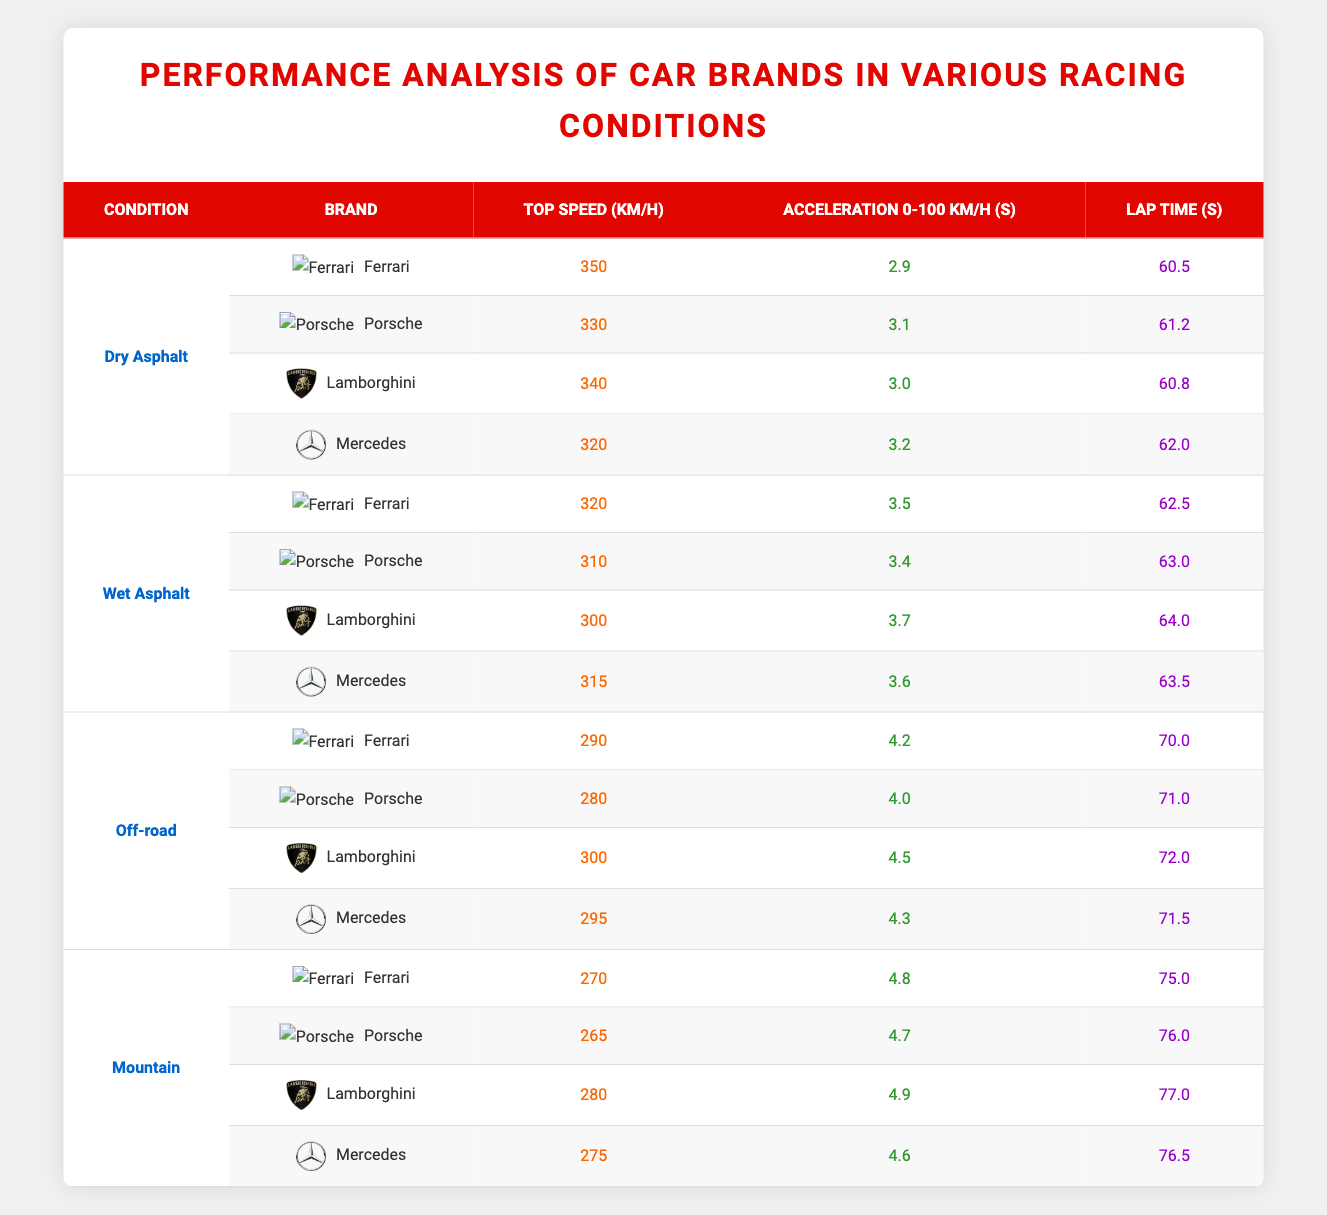What is the top speed of the Ferrari on Dry Asphalt? From the table under the "Dry Asphalt" condition, the top speed of Ferrari is listed as 350 km/h.
Answer: 350 km/h Which brand has the fastest lap time on Wet Asphalt? By examining the lap times under the "Wet Asphalt" conditions, Porsche has the fastest lap time at 63.0 seconds.
Answer: Porsche What is the difference in top speed between Lamborghini and Mercedes on Dry Asphalt? The top speed of Lamborghini on Dry Asphalt is 340 km/h and Mercedes is 320 km/h. The difference is 340 - 320 = 20 km/h.
Answer: 20 km/h Is Ferrari's acceleration from 0 to 100 km/h on Off-road better than Lamborghini's? Ferrari has an acceleration of 4.2 seconds while Lamborghini has 4.5 seconds. Since 4.2 < 4.5, Ferrari's acceleration is better.
Answer: Yes What is the average lap time of all brands on Mountain conditions? The lap times on Mountain are 75.0, 76.0, 77.0, and 76.5 seconds for Ferrari, Porsche, Lamborghini, and Mercedes respectively. The average is calculated as (75.0 + 76.0 + 77.0 + 76.5) / 4 = 76.13 seconds.
Answer: 76.13 seconds Which brand has consistent performance across all racing conditions? To determine consistency, we look at both lap times and acceleration. Mercedes has the least variation in lap times and acceleration across different conditions.
Answer: Mercedes What is the lowest top speed recorded in Off-road conditions? Upon reviewing the Off-road statistics, the lowest top speed is from Porsche, at 280 km/h.
Answer: 280 km/h Can we say that the Porsche performs better than Mercedes in Wet Asphalt conditions? In Wet Asphalt, Porsche's top speed is 310 km/h whereas Mercedes's top speed is 315 km/h. Therefore, Porsche does not perform better than Mercedes in this context.
Answer: No What is the total sum of lap times for all brands under Dry Asphalt? The lap times for Dry Asphalt are 60.5, 61.2, 60.8, and 62.0 seconds. Their total sum is calculated as 60.5 + 61.2 + 60.8 + 62.0 = 244.5 seconds.
Answer: 244.5 seconds 